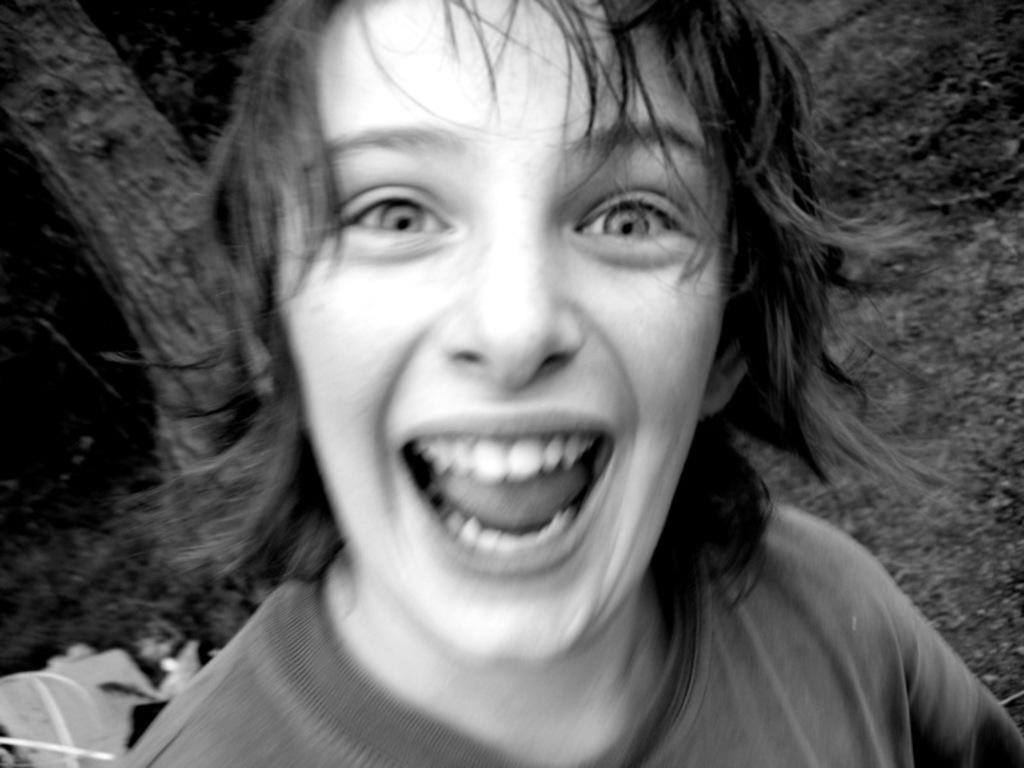What is the color scheme of the image? The image is black and white. Can you describe the person in the image? There is a person in the image, and they are smiling. What can be seen in the background of the image? The background of the image is dark. What is located on the left side of the image? There are objects on the left side of the image. What type of test can be seen being conducted in the image? There is no test being conducted in the image; it features a person smiling with a dark background and objects on the left side. Can you describe the cushion that the person is sitting on in the image? There is no cushion present in the image; it only features a person, a dark background, and objects on the left side. 